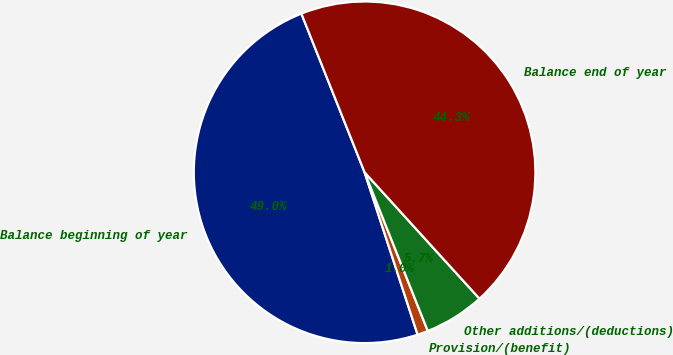<chart> <loc_0><loc_0><loc_500><loc_500><pie_chart><fcel>Balance beginning of year<fcel>Provision/(benefit)<fcel>Other additions/(deductions)<fcel>Balance end of year<nl><fcel>48.99%<fcel>1.01%<fcel>5.71%<fcel>44.29%<nl></chart> 